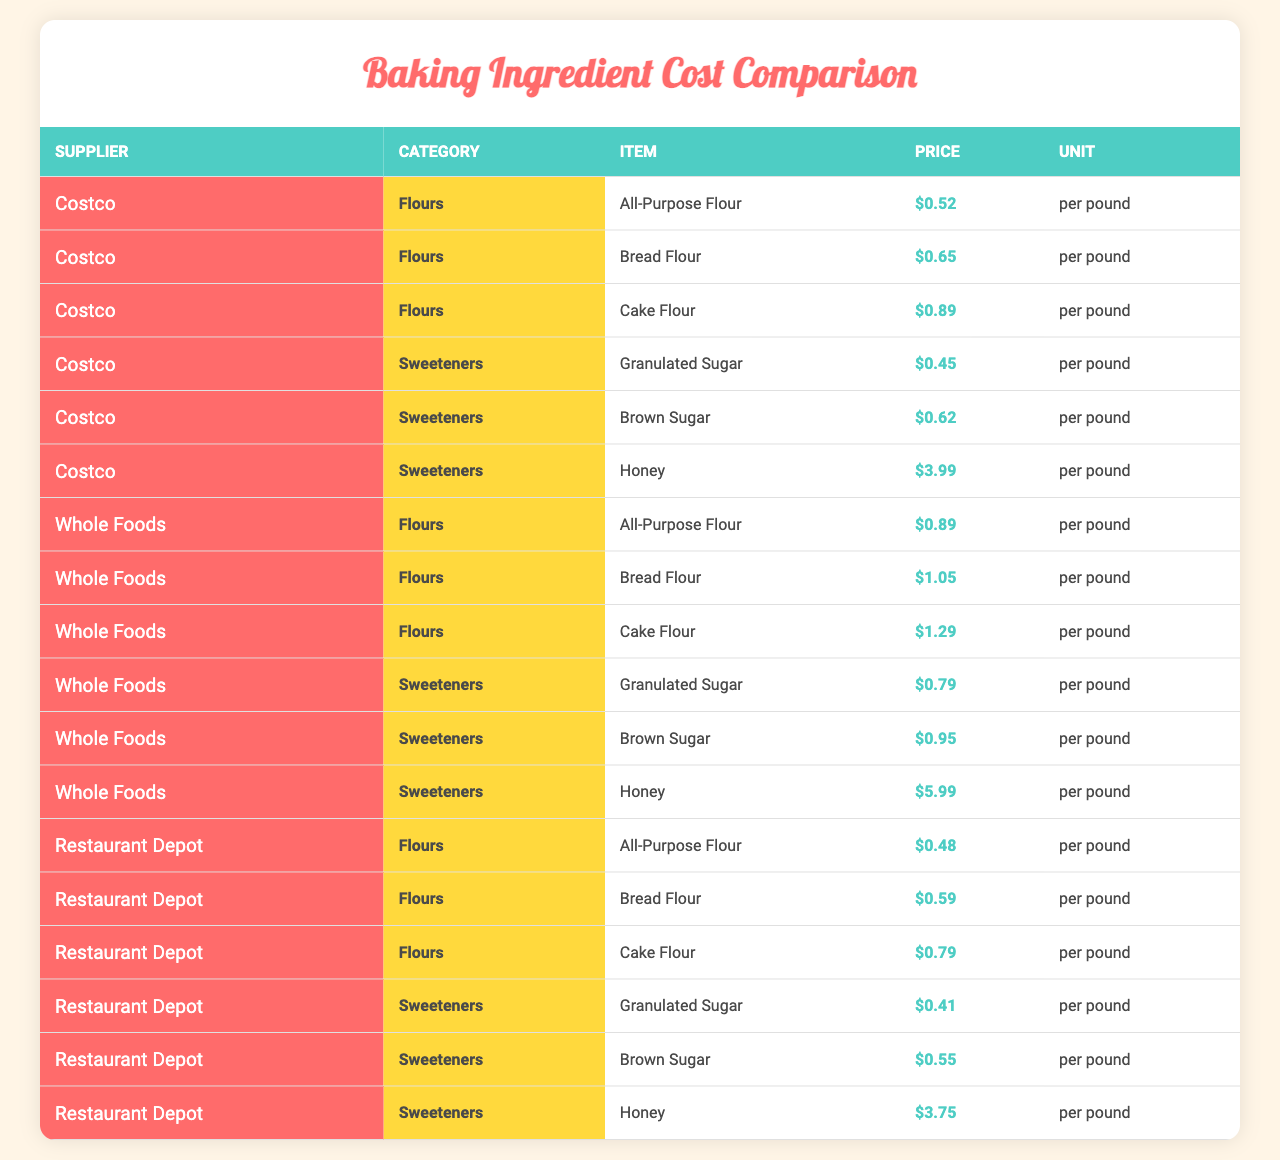What is the price of All-Purpose Flour at Costco? In the table, I look at the row corresponding to Costco in the Flours category for the All-Purpose Flour item. The price listed is $0.52 per pound.
Answer: $0.52 Which supplier offers the lowest price for Granulated Sugar? I compare the prices for Granulated Sugar listed under each supplier. Costco has a price of $0.45, Whole Foods has $0.79, and Restaurant Depot has $0.41. The lowest price is $0.41 at Restaurant Depot.
Answer: Restaurant Depot What is the price difference between Bread Flour at Costco and Whole Foods? I find the price of Bread Flour at Costco, which is $0.65, and at Whole Foods, which is $1.05. The difference is calculated as $1.05 - $0.65 = $0.40.
Answer: $0.40 Is Honey more expensive at Whole Foods compared to Costco? I compare the price of Honey at Both suppliers. Honey costs $3.99 at Costco and $5.99 at Whole Foods. Since $3.99 is less than $5.99, the statement is true.
Answer: Yes What is the average price of Cake Flour across all suppliers? The prices for Cake Flour are $0.89 (Costco), $1.29 (Whole Foods), and $0.79 (Restaurant Depot). First, I sum these prices: $0.89 + $1.29 + $0.79 = $2.97. There are three items, so I divide $2.97 by 3 to find the average: $2.97 / 3 = $0.99.
Answer: $0.99 Which supplier has the highest price for Brown Sugar? I check the price of Brown Sugar for each supplier. Costco has $0.62, Whole Foods has $0.95, and Restaurant Depot has $0.55. The highest price is $0.95 at Whole Foods.
Answer: Whole Foods What is the total cost of purchasing all types of flours from Restaurant Depot? First, I find the prices of all the flours from Restaurant Depot: All-Purpose Flour is $0.48, Bread Flour is $0.59, and Cake Flour is $0.79. Then, I add these prices together: $0.48 + $0.59 + $0.79 = $1.86.
Answer: $1.86 Which item from Costco has the highest price? I look through all items from Costco. The prices are: All-Purpose Flour ($0.52), Bread Flour ($0.65), Cake Flour ($0.89), Granulated Sugar ($0.45), Brown Sugar ($0.62), and Honey ($3.99). The highest price is $3.99 for Honey.
Answer: Honey What percentage more expensive is Cake Flour at Whole Foods compared to Restaurant Depot? First, I find the prices: Cake Flour at Whole Foods is $1.29, and at Restaurant Depot, it's $0.79. The difference is $1.29 - $0.79 = $0.50. To find the percentage increase, I calculate: ($0.50 / $0.79) * 100 ≈ 63.29%.
Answer: 63.29% What is the total price for purchasing Granulated Sugar and Honey from Costco? I find the prices for Granulated Sugar ($0.45) and Honey ($3.99) from Costco. I then add these amounts: $0.45 + $3.99 = $4.44.
Answer: $4.44 